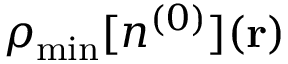<formula> <loc_0><loc_0><loc_500><loc_500>\rho _ { \min } [ n ^ { ( 0 ) } ] ( { r } )</formula> 